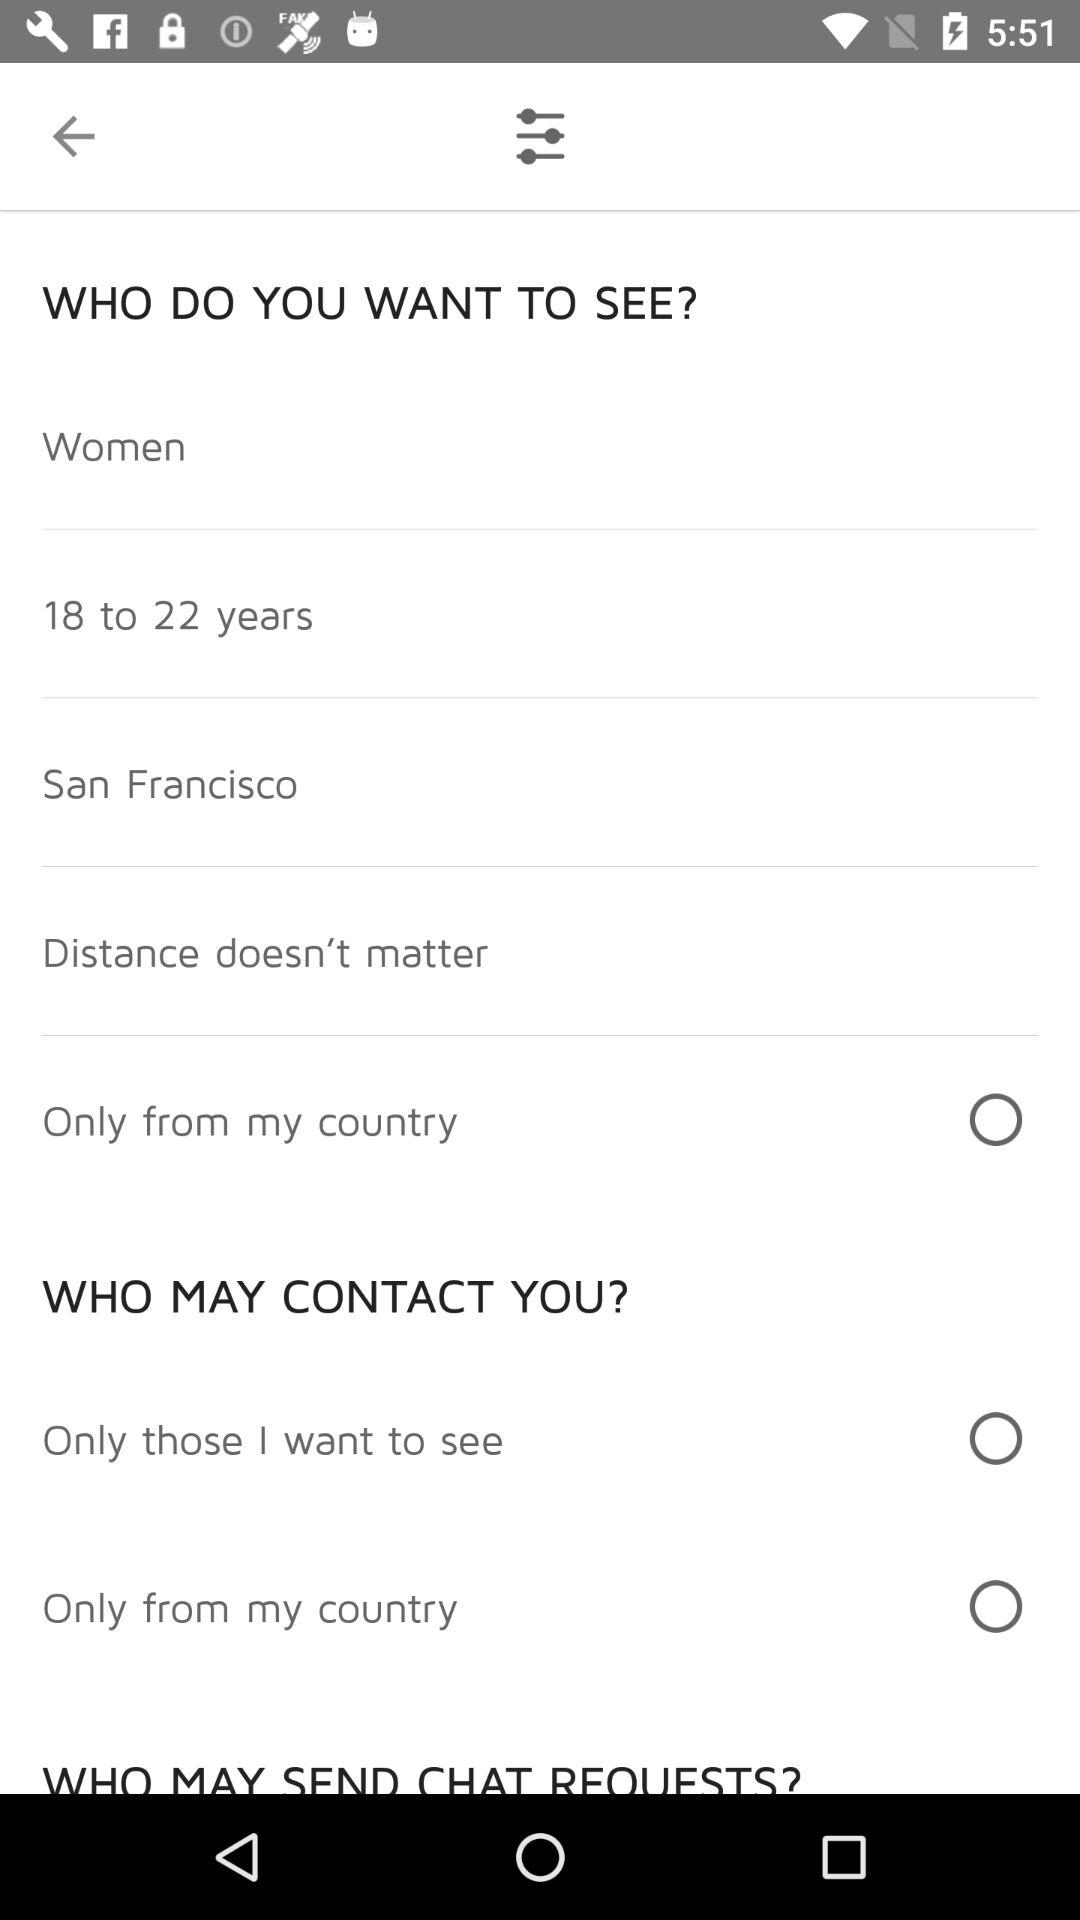What location's people does the user want to see? The user want to see San Francisco people. 